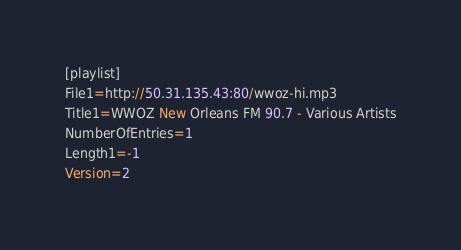<code> <loc_0><loc_0><loc_500><loc_500><_SQL_>[playlist]
File1=http://50.31.135.43:80/wwoz-hi.mp3
Title1=WWOZ New Orleans FM 90.7 - Various Artists
NumberOfEntries=1
Length1=-1
Version=2
</code> 